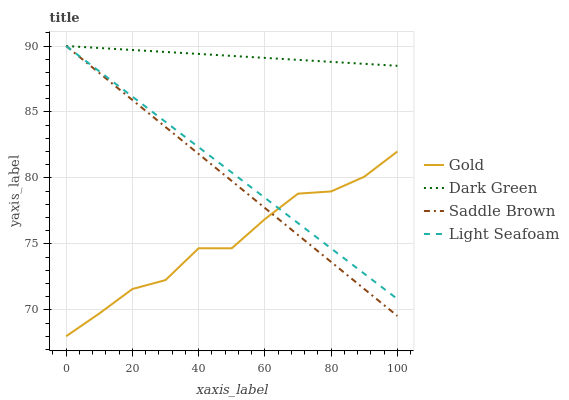Does Gold have the minimum area under the curve?
Answer yes or no. Yes. Does Dark Green have the maximum area under the curve?
Answer yes or no. Yes. Does Saddle Brown have the minimum area under the curve?
Answer yes or no. No. Does Saddle Brown have the maximum area under the curve?
Answer yes or no. No. Is Saddle Brown the smoothest?
Answer yes or no. Yes. Is Gold the roughest?
Answer yes or no. Yes. Is Gold the smoothest?
Answer yes or no. No. Is Saddle Brown the roughest?
Answer yes or no. No. Does Gold have the lowest value?
Answer yes or no. Yes. Does Saddle Brown have the lowest value?
Answer yes or no. No. Does Dark Green have the highest value?
Answer yes or no. Yes. Does Gold have the highest value?
Answer yes or no. No. Is Gold less than Dark Green?
Answer yes or no. Yes. Is Dark Green greater than Gold?
Answer yes or no. Yes. Does Saddle Brown intersect Gold?
Answer yes or no. Yes. Is Saddle Brown less than Gold?
Answer yes or no. No. Is Saddle Brown greater than Gold?
Answer yes or no. No. Does Gold intersect Dark Green?
Answer yes or no. No. 